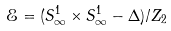Convert formula to latex. <formula><loc_0><loc_0><loc_500><loc_500>\mathcal { E } = ( S _ { \infty } ^ { 1 } \times S _ { \infty } ^ { 1 } - \Delta ) / Z _ { 2 }</formula> 